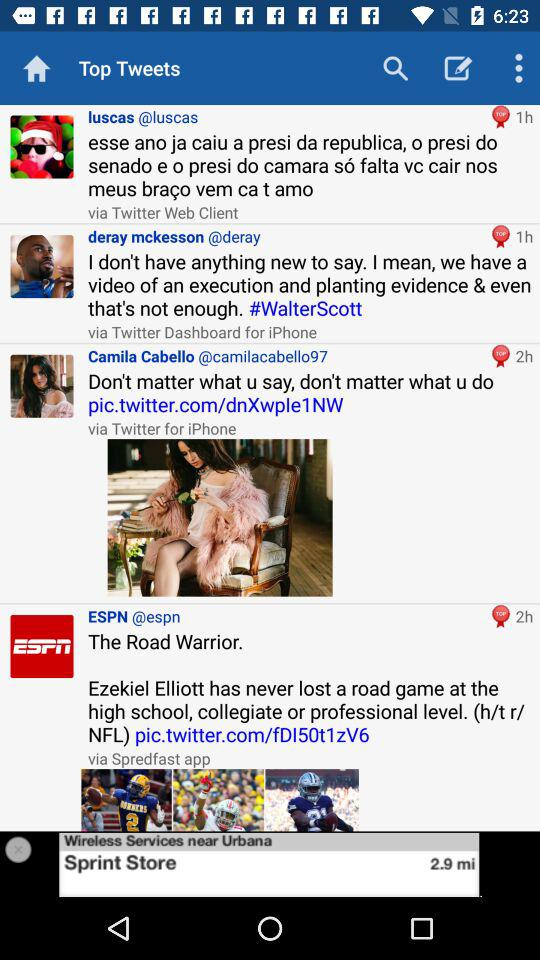How many hours ago did ESPN post a tweet? ESPN posted a tweet 2 hours ago. 